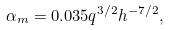<formula> <loc_0><loc_0><loc_500><loc_500>\alpha _ { m } = 0 . 0 3 5 q ^ { 3 / 2 } h ^ { - 7 / 2 } ,</formula> 